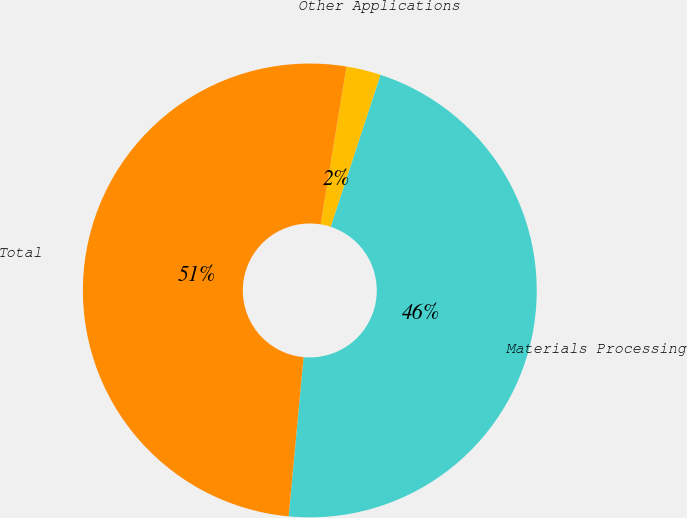<chart> <loc_0><loc_0><loc_500><loc_500><pie_chart><fcel>Materials Processing<fcel>Other Applications<fcel>Total<nl><fcel>46.45%<fcel>2.45%<fcel>51.1%<nl></chart> 